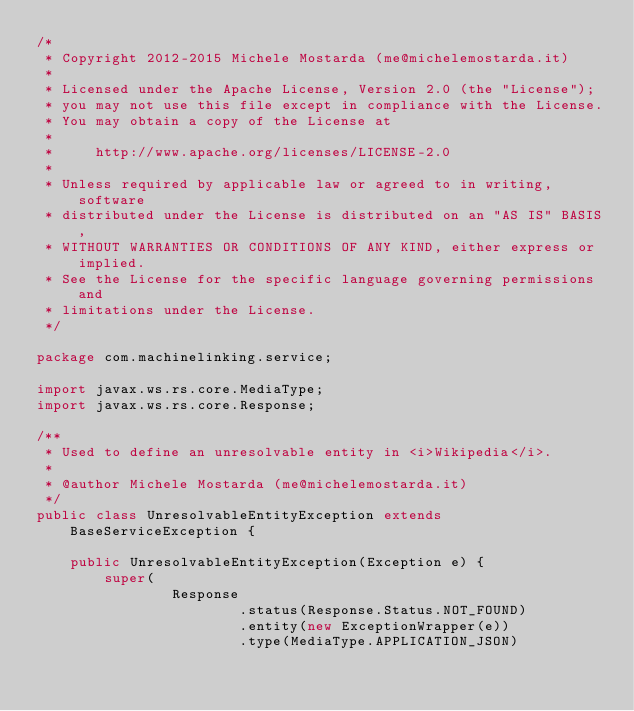<code> <loc_0><loc_0><loc_500><loc_500><_Java_>/*
 * Copyright 2012-2015 Michele Mostarda (me@michelemostarda.it)
 *
 * Licensed under the Apache License, Version 2.0 (the "License");
 * you may not use this file except in compliance with the License.
 * You may obtain a copy of the License at
 *
 *     http://www.apache.org/licenses/LICENSE-2.0
 *
 * Unless required by applicable law or agreed to in writing, software
 * distributed under the License is distributed on an "AS IS" BASIS,
 * WITHOUT WARRANTIES OR CONDITIONS OF ANY KIND, either express or implied.
 * See the License for the specific language governing permissions and
 * limitations under the License.
 */

package com.machinelinking.service;

import javax.ws.rs.core.MediaType;
import javax.ws.rs.core.Response;

/**
 * Used to define an unresolvable entity in <i>Wikipedia</i>.
 *
 * @author Michele Mostarda (me@michelemostarda.it)
 */
public class UnresolvableEntityException extends BaseServiceException {

    public UnresolvableEntityException(Exception e) {
        super(
                Response
                        .status(Response.Status.NOT_FOUND)
                        .entity(new ExceptionWrapper(e))
                        .type(MediaType.APPLICATION_JSON)</code> 